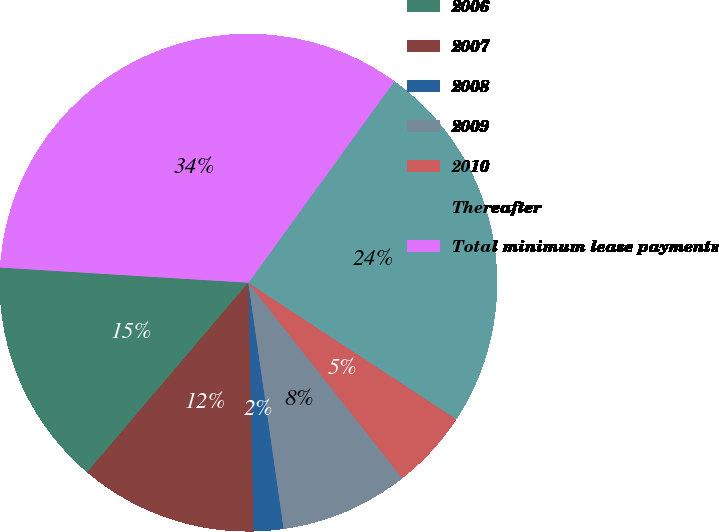<chart> <loc_0><loc_0><loc_500><loc_500><pie_chart><fcel>2006<fcel>2007<fcel>2008<fcel>2009<fcel>2010<fcel>Thereafter<fcel>Total minimum lease payments<nl><fcel>14.76%<fcel>11.55%<fcel>1.93%<fcel>8.35%<fcel>5.14%<fcel>24.26%<fcel>34.01%<nl></chart> 